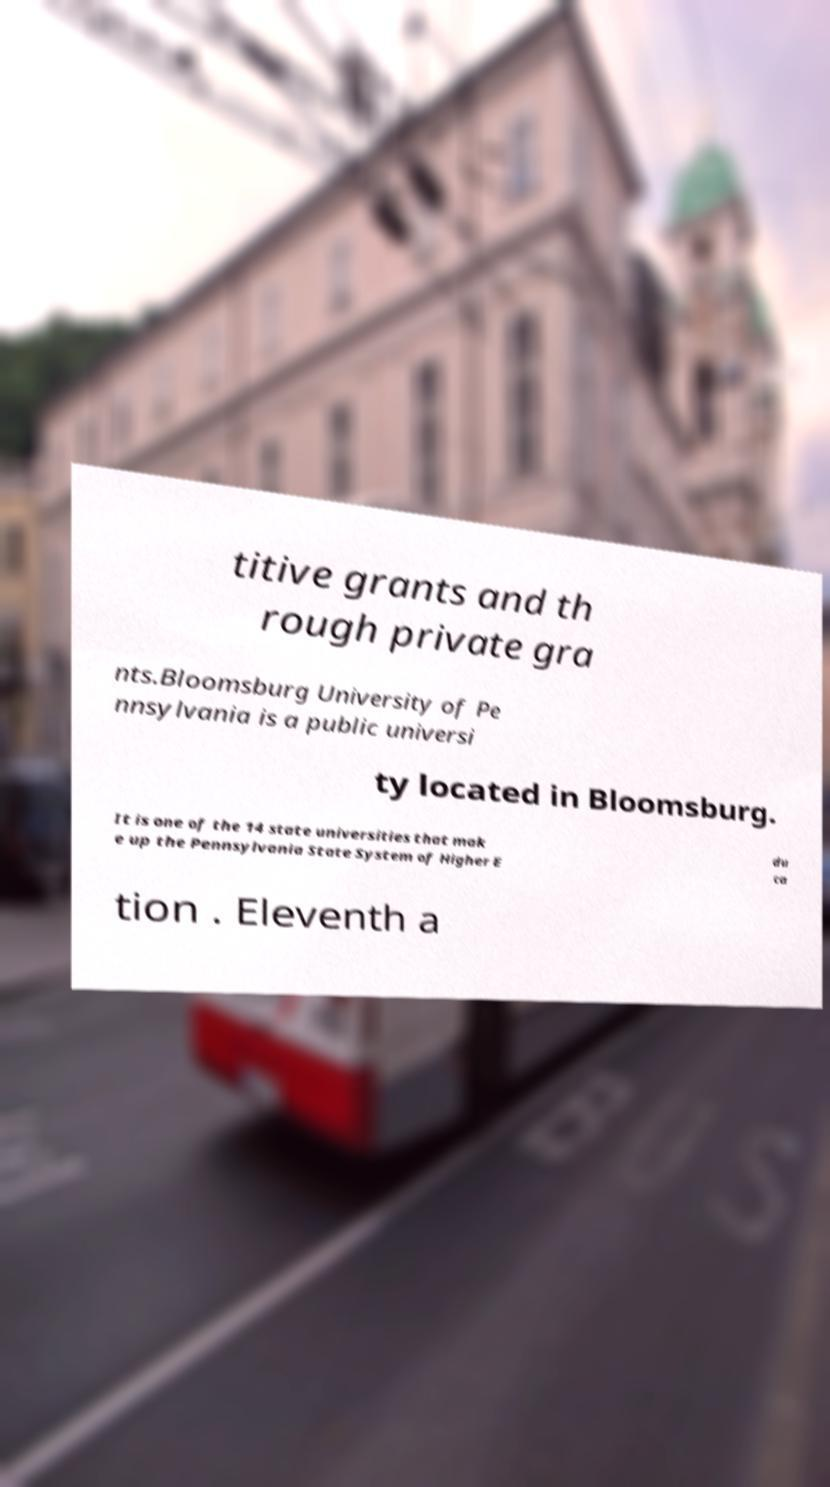Please identify and transcribe the text found in this image. titive grants and th rough private gra nts.Bloomsburg University of Pe nnsylvania is a public universi ty located in Bloomsburg. It is one of the 14 state universities that mak e up the Pennsylvania State System of Higher E du ca tion . Eleventh a 